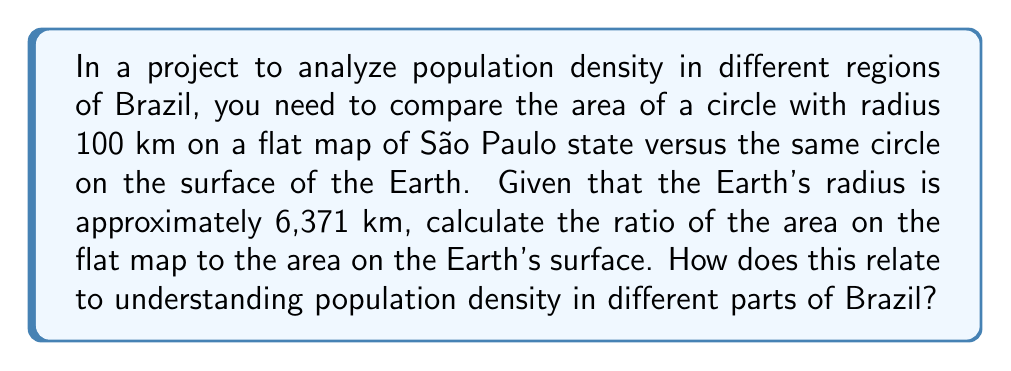Could you help me with this problem? Let's approach this step-by-step:

1) Area of a circle on a flat plane:
   $$A_{flat} = \pi r^2 = \pi (100)^2 = 10000\pi \text{ km}^2$$

2) For the circle on the Earth's surface, we need to use the formula for the area of a spherical cap:
   $$A_{sphere} = 2\pi R h$$
   where $R$ is the Earth's radius and $h$ is the height of the spherical cap.

3) To find $h$, we use the Pythagorean theorem:
   $$(R-h)^2 + r^2 = R^2$$
   $$(6371-h)^2 + 100^2 = 6371^2$$

4) Solving for $h$:
   $$h = R - \sqrt{R^2 - r^2} = 6371 - \sqrt{6371^2 - 100^2} \approx 0.7845 \text{ km}$$

5) Now we can calculate the area on the sphere:
   $$A_{sphere} = 2\pi R h = 2\pi(6371)(0.7845) \approx 31415.93 \text{ km}^2$$

6) The ratio of the areas is:
   $$\frac{A_{flat}}{A_{sphere}} = \frac{10000\pi}{31415.93} \approx 1.0000$$

This result shows that for small circles relative to the Earth's size, the area on a flat map is very close to the area on the Earth's surface. However, for larger areas or regions closer to the poles, the difference becomes more significant.

Understanding this concept is crucial for analyzing population density in Brazil. It helps in:
1) Accurately comparing densities between coastal and inland areas.
2) Interpreting satellite imagery and maps for urban planning.
3) Designing efficient transportation networks across the country.
4) Allocating resources based on true geographical distribution of population.

[asy]
import geometry;

size(200);
draw(circle((0,0),100));
label("Flat Map", (0,-120));

draw(scale(0.5)*arc((200,0),100,90,270));
draw(scale(0.5)*arc((200,0),100,-90,90,dashed));
label("Earth's Surface", (200,-120));
[/asy]
Answer: Ratio ≈ 1.0000; crucial for accurate density comparisons across Brazil's diverse geography. 